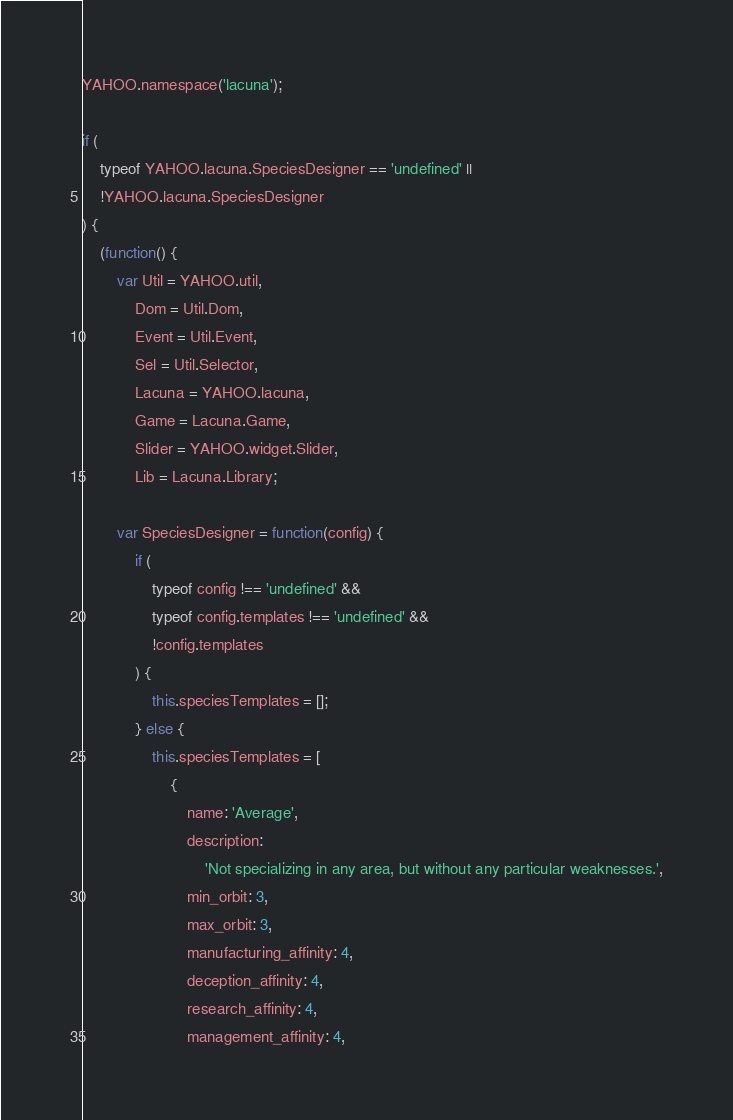<code> <loc_0><loc_0><loc_500><loc_500><_JavaScript_>YAHOO.namespace('lacuna');

if (
    typeof YAHOO.lacuna.SpeciesDesigner == 'undefined' ||
    !YAHOO.lacuna.SpeciesDesigner
) {
    (function() {
        var Util = YAHOO.util,
            Dom = Util.Dom,
            Event = Util.Event,
            Sel = Util.Selector,
            Lacuna = YAHOO.lacuna,
            Game = Lacuna.Game,
            Slider = YAHOO.widget.Slider,
            Lib = Lacuna.Library;

        var SpeciesDesigner = function(config) {
            if (
                typeof config !== 'undefined' &&
                typeof config.templates !== 'undefined' &&
                !config.templates
            ) {
                this.speciesTemplates = [];
            } else {
                this.speciesTemplates = [
                    {
                        name: 'Average',
                        description:
                            'Not specializing in any area, but without any particular weaknesses.',
                        min_orbit: 3,
                        max_orbit: 3,
                        manufacturing_affinity: 4,
                        deception_affinity: 4,
                        research_affinity: 4,
                        management_affinity: 4,</code> 